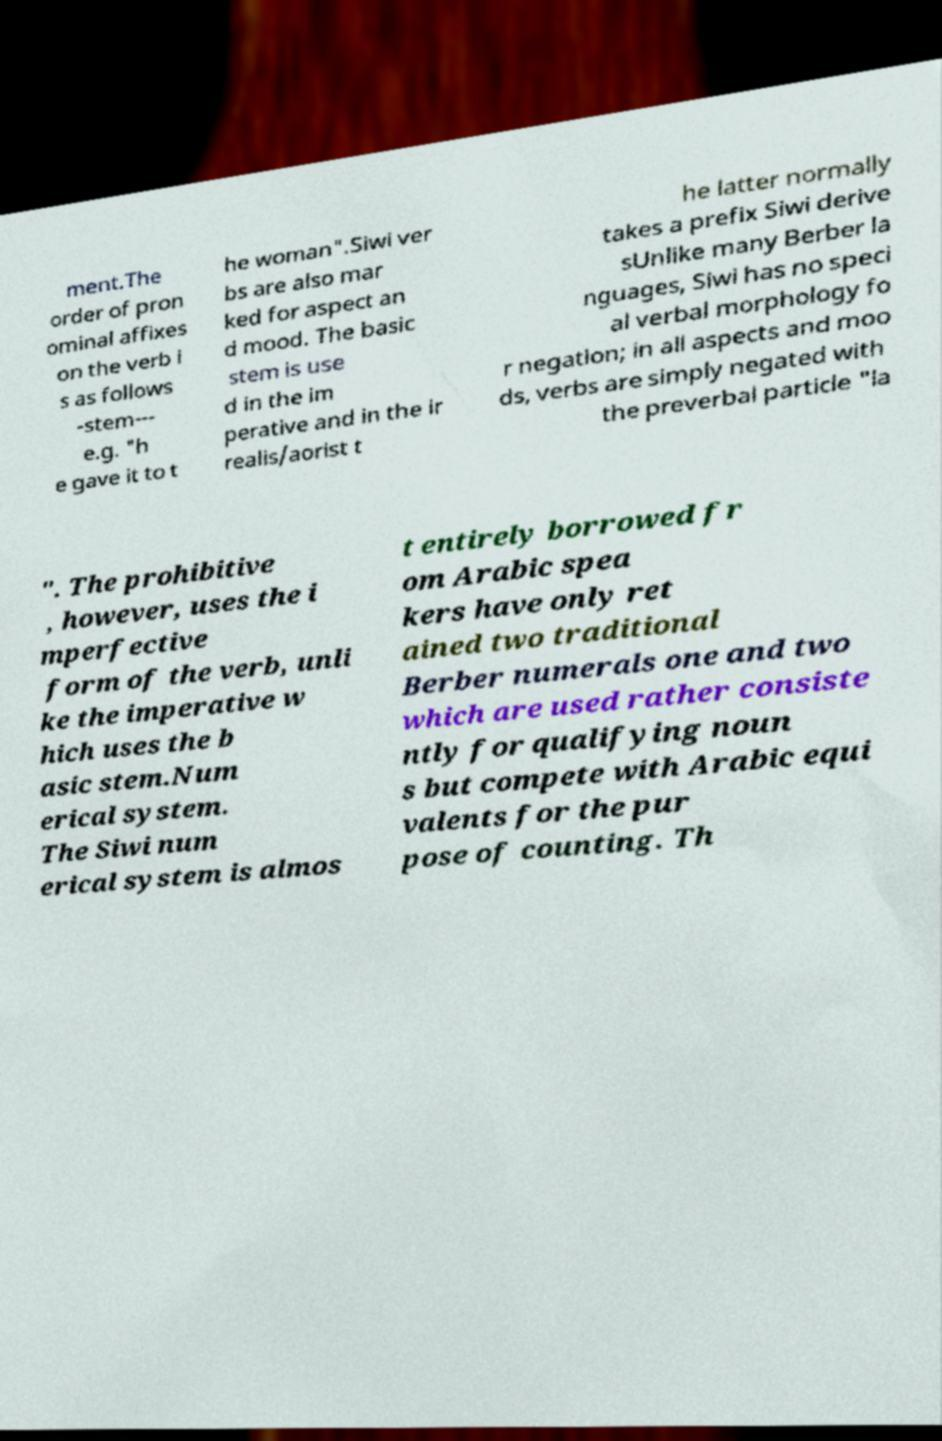Could you assist in decoding the text presented in this image and type it out clearly? ment.The order of pron ominal affixes on the verb i s as follows -stem--- e.g. "h e gave it to t he woman".Siwi ver bs are also mar ked for aspect an d mood. The basic stem is use d in the im perative and in the ir realis/aorist t he latter normally takes a prefix Siwi derive sUnlike many Berber la nguages, Siwi has no speci al verbal morphology fo r negation; in all aspects and moo ds, verbs are simply negated with the preverbal particle "la ". The prohibitive , however, uses the i mperfective form of the verb, unli ke the imperative w hich uses the b asic stem.Num erical system. The Siwi num erical system is almos t entirely borrowed fr om Arabic spea kers have only ret ained two traditional Berber numerals one and two which are used rather consiste ntly for qualifying noun s but compete with Arabic equi valents for the pur pose of counting. Th 